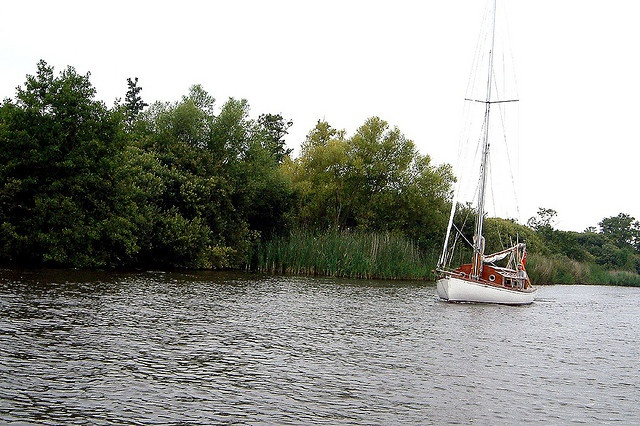Describe the objects in this image and their specific colors. I can see a boat in white, lightgray, black, darkgray, and gray tones in this image. 